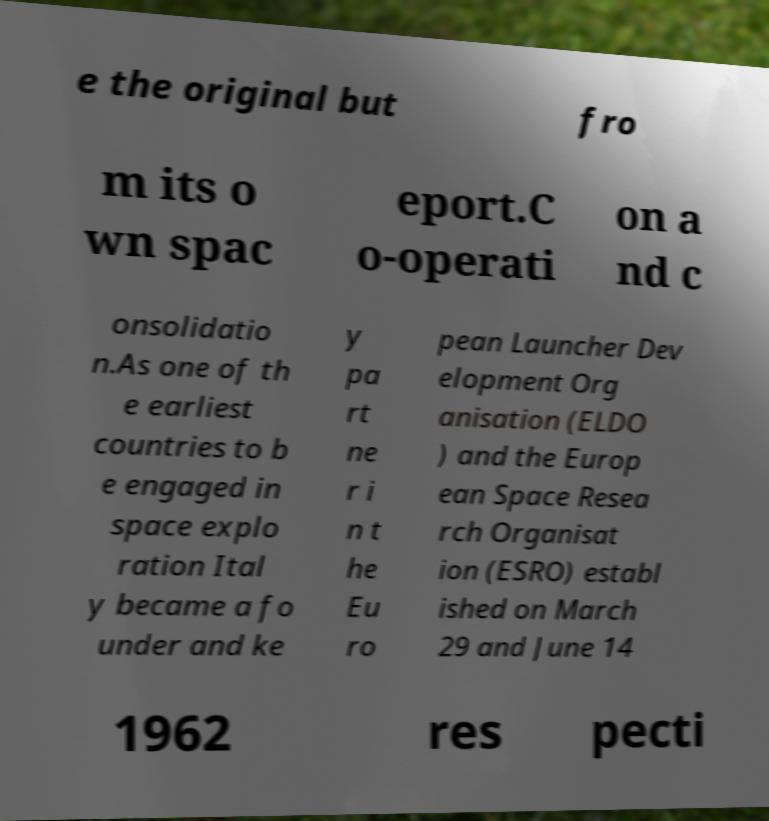Please identify and transcribe the text found in this image. e the original but fro m its o wn spac eport.C o-operati on a nd c onsolidatio n.As one of th e earliest countries to b e engaged in space explo ration Ital y became a fo under and ke y pa rt ne r i n t he Eu ro pean Launcher Dev elopment Org anisation (ELDO ) and the Europ ean Space Resea rch Organisat ion (ESRO) establ ished on March 29 and June 14 1962 res pecti 